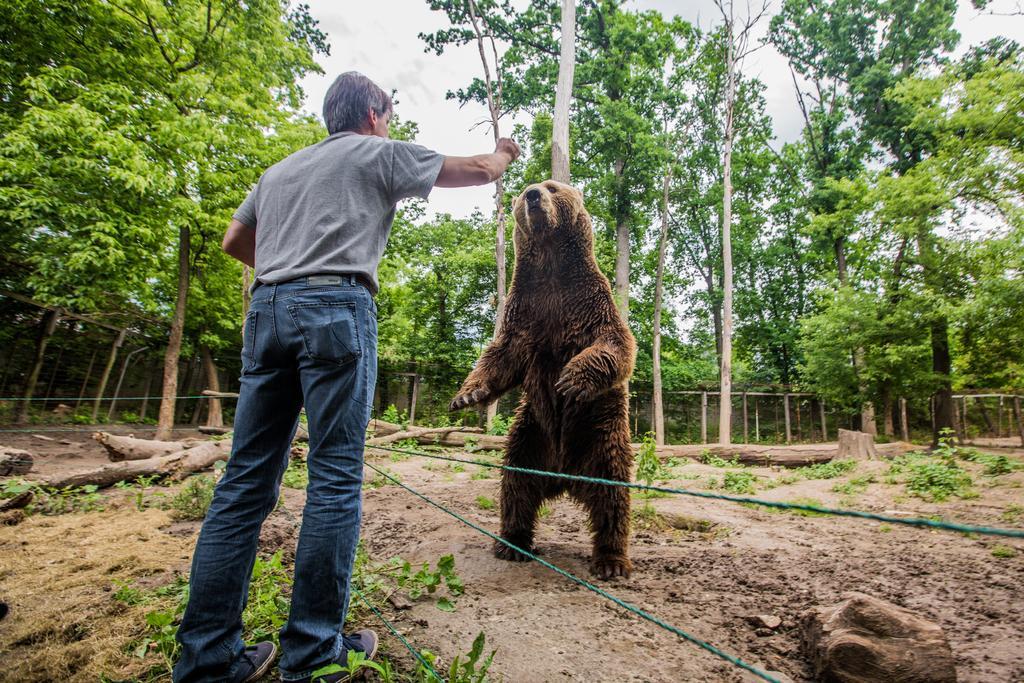How would you summarize this image in a sentence or two? In the foreground of the picture there are plants, dry grass and a person standing. In the picture there is a bear. In the background there are trees and a wall. Sky is cloudy. In the center of the picture there are wooden logs, plants and mud. 